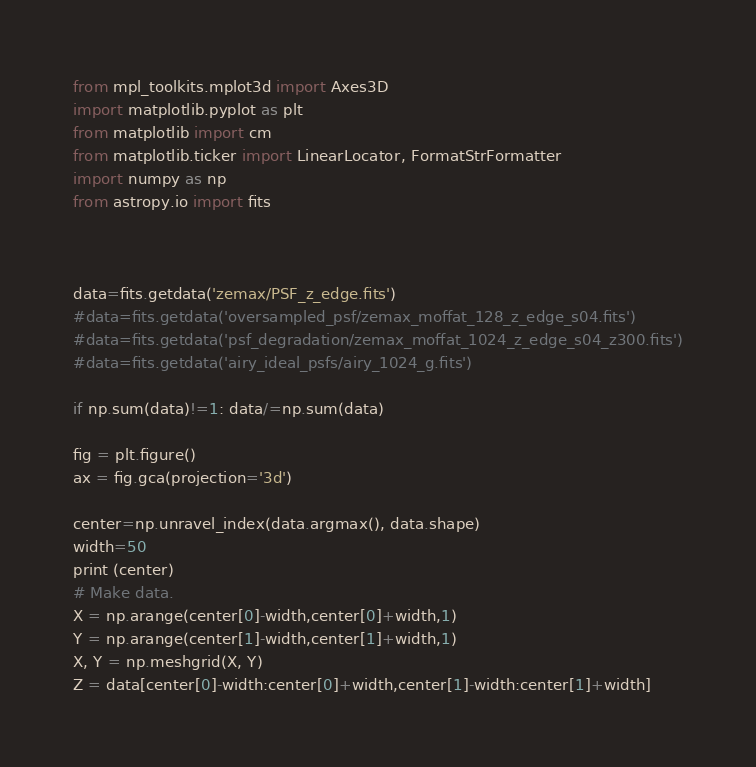Convert code to text. <code><loc_0><loc_0><loc_500><loc_500><_Python_>from mpl_toolkits.mplot3d import Axes3D
import matplotlib.pyplot as plt
from matplotlib import cm
from matplotlib.ticker import LinearLocator, FormatStrFormatter
import numpy as np
from astropy.io import fits



data=fits.getdata('zemax/PSF_z_edge.fits')
#data=fits.getdata('oversampled_psf/zemax_moffat_128_z_edge_s04.fits')
#data=fits.getdata('psf_degradation/zemax_moffat_1024_z_edge_s04_z300.fits')
#data=fits.getdata('airy_ideal_psfs/airy_1024_g.fits')

if np.sum(data)!=1: data/=np.sum(data)

fig = plt.figure()
ax = fig.gca(projection='3d')

center=np.unravel_index(data.argmax(), data.shape)
width=50
print (center)
# Make data.
X = np.arange(center[0]-width,center[0]+width,1)
Y = np.arange(center[1]-width,center[1]+width,1)
X, Y = np.meshgrid(X, Y)
Z = data[center[0]-width:center[0]+width,center[1]-width:center[1]+width]</code> 